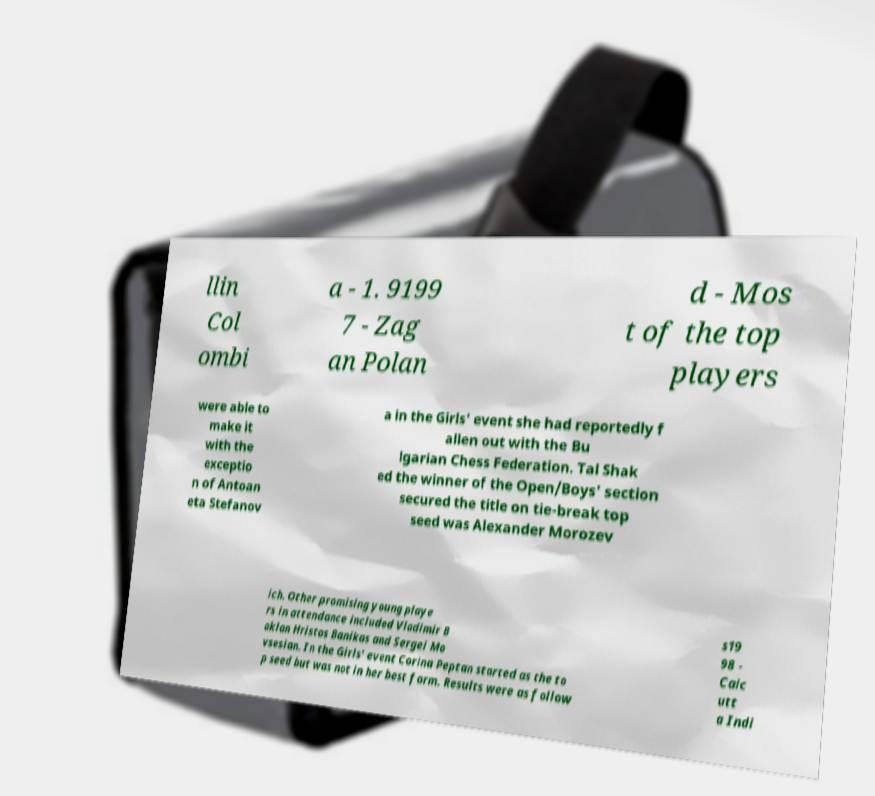What messages or text are displayed in this image? I need them in a readable, typed format. llin Col ombi a - 1. 9199 7 - Zag an Polan d - Mos t of the top players were able to make it with the exceptio n of Antoan eta Stefanov a in the Girls' event she had reportedly f allen out with the Bu lgarian Chess Federation. Tal Shak ed the winner of the Open/Boys' section secured the title on tie-break top seed was Alexander Morozev ich. Other promising young playe rs in attendance included Vladimir B aklan Hristos Banikas and Sergei Mo vsesian. In the Girls' event Corina Peptan started as the to p seed but was not in her best form. Results were as follow s19 98 - Calc utt a Indi 